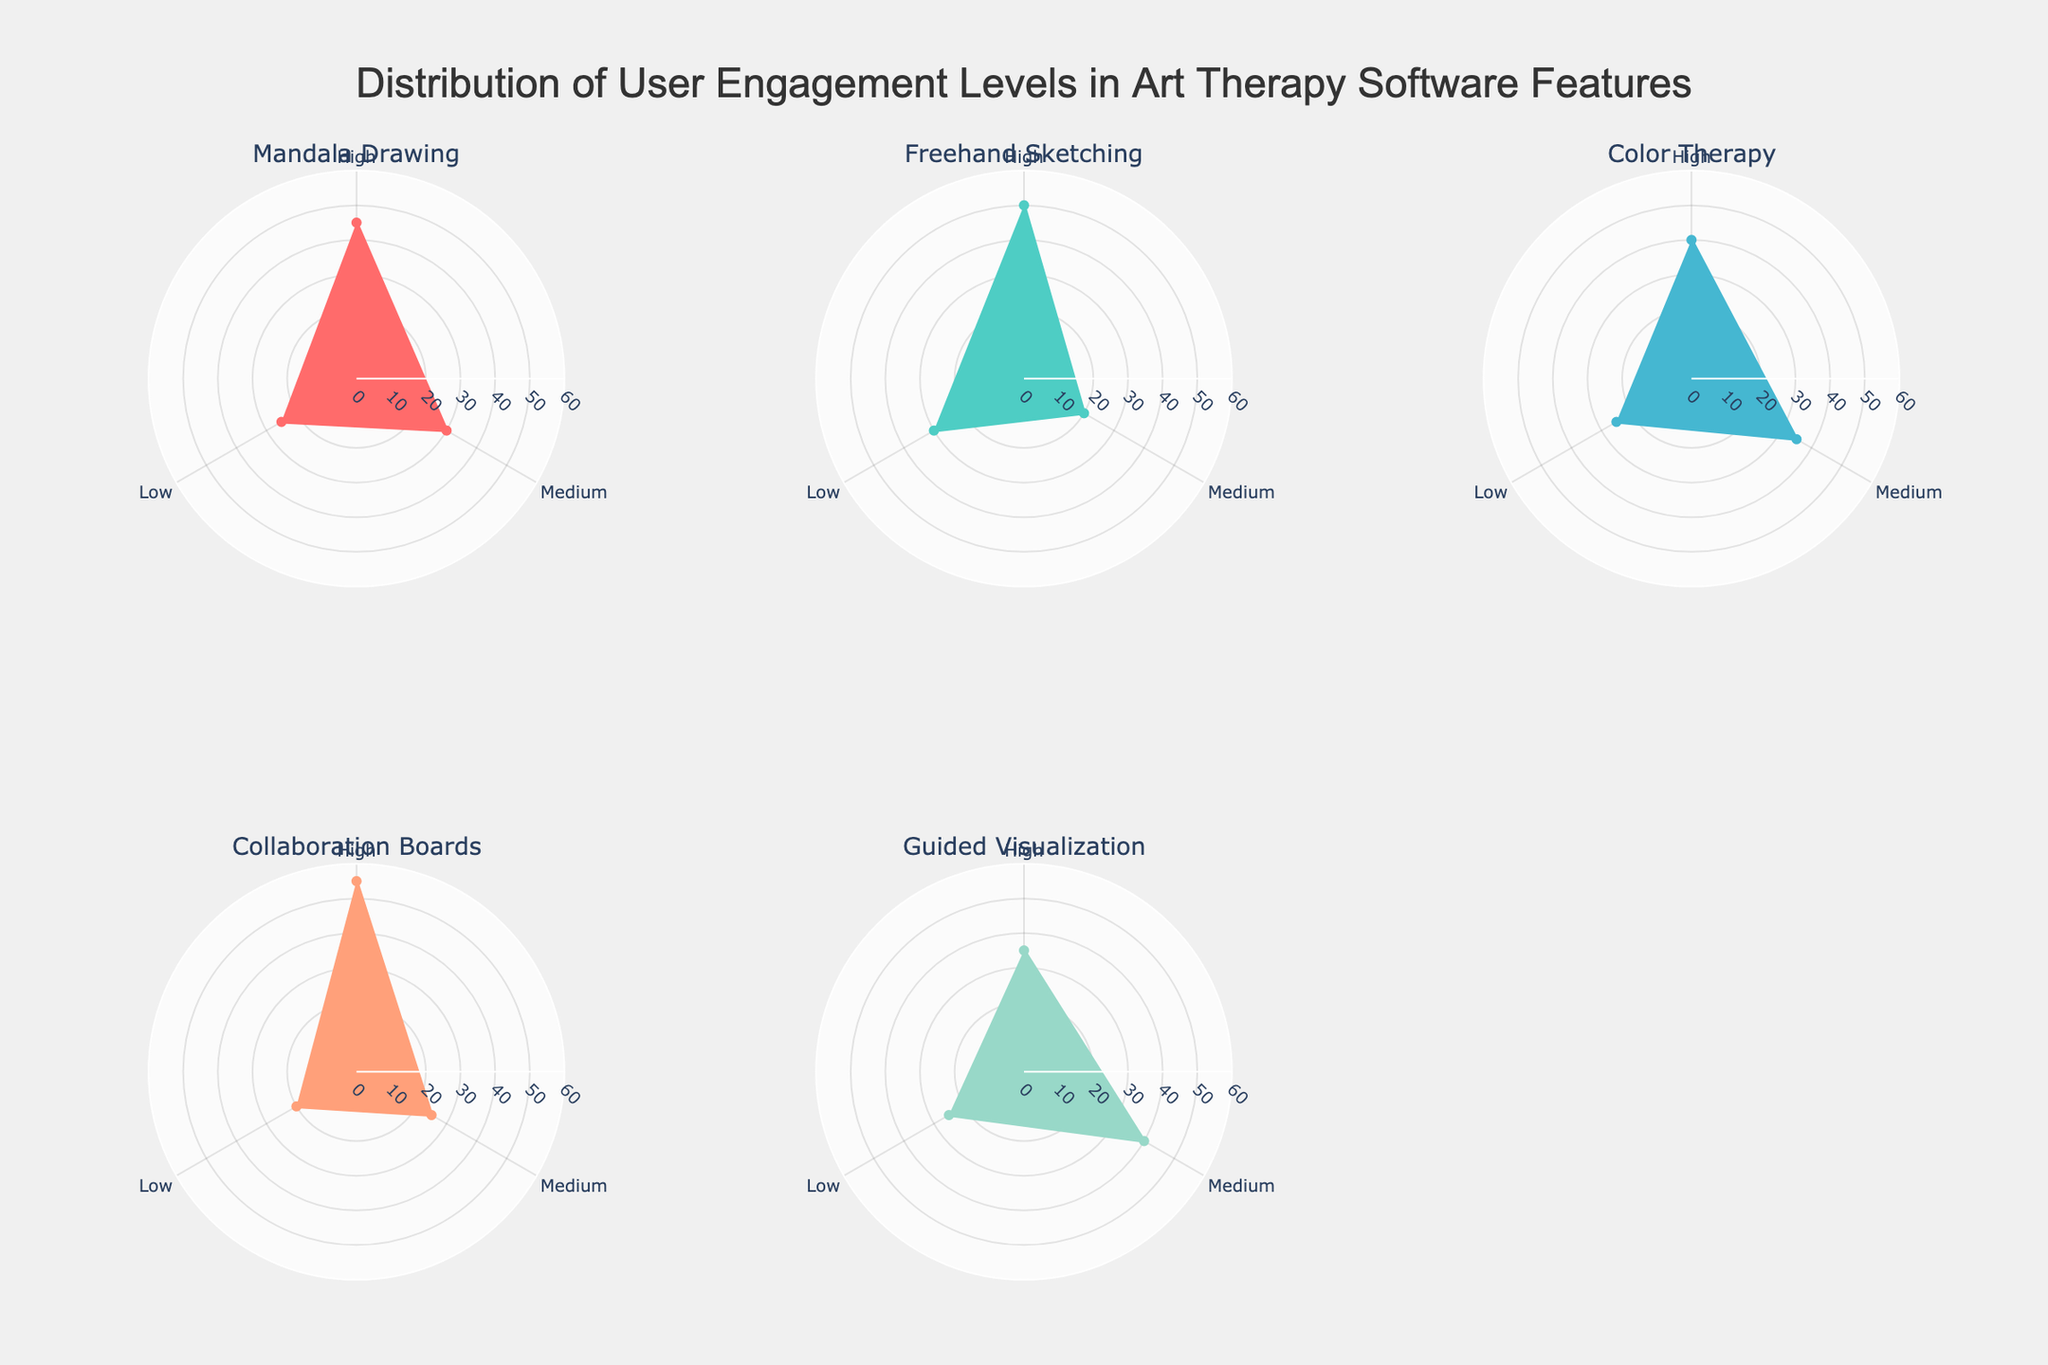What is the title of the figure? The title is usually located at the top of the figure. It summarizes the main theme or subject that the figure represents. In this case, it reads "Distribution of User Engagement Levels in Art Therapy Software Features".
Answer: Distribution of User Engagement Levels in Art Therapy Software Features How many features are represented in the figure? You can count the number of subplot titles to determine how many features are represented. There are six subplot titles, indicating six features.
Answer: Six Which feature has the highest percentage of high user engagement? Look for the radial segment that has the greatest value within each polar chart and then identify the feature associated with the highest value. The Collaboration Boards feature has the highest high engagement percentage at 55%.
Answer: Collaboration Boards Which user engagement level has the lowest percentage for Freehand Sketching? Observe the segments under Freehand Sketching. The segment with the lowest value is Low user engagement with a percentage of 20%.
Answer: Low Compare the high user engagement percentages between Mandala Drawing and Color Therapy. Which one is higher? Look at the high-user engagement percentages in the corresponding sections of Mandala Drawing and Color Therapy. Mandala Drawing has 45% while Color Therapy has 40%, hence Mandala Drawing is higher.
Answer: Mandala Drawing Which feature has the highest percentage of medium user engagement? Determine the feature by observing the segments for medium user engagement in each subplot. Guided Visualization has the highest percentage of medium user engagement at 40%.
Answer: Guided Visualization What is the combined percentage of low user engagement for Mandala Drawing and Freehand Sketching? Add the percentages of low user engagement for both features. Mandala Drawing has 25% and Freehand Sketching has 30%, combined they are 25 + 30 = 55%.
Answer: 55% Which feature has the overall most balanced distribution of user engagement levels? To answer this, look for the feature where the percentages across high, medium, and low user engagement levels are closest to each other. Color Therapy has 40% high, 35% medium, and 25% low which is relatively balanced.
Answer: Color Therapy Is the medium user engagement percentage for Mandala Drawing greater than that for Collaboration Boards? Compare the medium user engagement percentages of the two features. Mandala Drawing has 30% while Collaboration Boards has 25%. Therefore, the medium engagement for Mandala Drawing is higher.
Answer: Yes How do the user engagement levels of Guided Visualization differ from those of Collaboration Boards? For a detailed comparison, observe all three engagement levels for both features. Guided Visualization has 35% high, 40% medium, 25% low while Collaboration Boards has 55% high, 25% medium, 20% low. The biggest differences are in high engagement (55% vs 35%) and medium engagement (25% vs 40%).
Answer: Higher in high engagement for Collaboration Boards, higher in medium engagement for Guided Visualization 